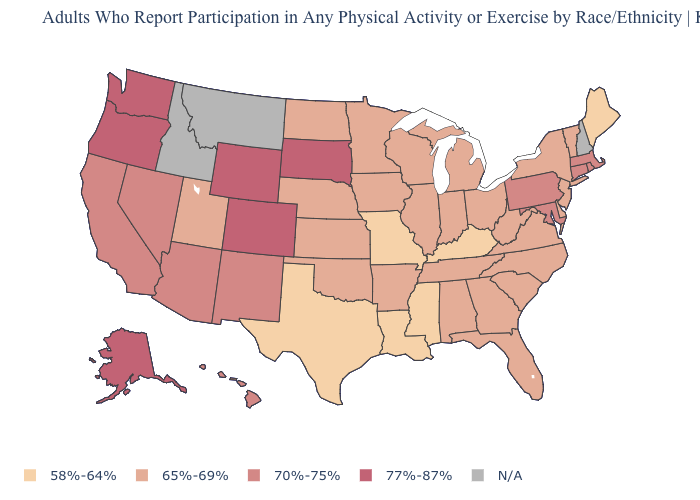How many symbols are there in the legend?
Give a very brief answer. 5. What is the value of Connecticut?
Short answer required. 70%-75%. Which states have the lowest value in the USA?
Short answer required. Kentucky, Louisiana, Maine, Mississippi, Missouri, Texas. Among the states that border California , which have the highest value?
Keep it brief. Oregon. What is the value of West Virginia?
Write a very short answer. 65%-69%. What is the value of Wyoming?
Answer briefly. 77%-87%. What is the lowest value in the USA?
Quick response, please. 58%-64%. What is the value of Tennessee?
Answer briefly. 65%-69%. Name the states that have a value in the range 65%-69%?
Quick response, please. Alabama, Arkansas, Delaware, Florida, Georgia, Illinois, Indiana, Iowa, Kansas, Michigan, Minnesota, Nebraska, New Jersey, New York, North Carolina, North Dakota, Ohio, Oklahoma, South Carolina, Tennessee, Utah, Vermont, Virginia, West Virginia, Wisconsin. What is the highest value in states that border Illinois?
Concise answer only. 65%-69%. Among the states that border Vermont , which have the highest value?
Write a very short answer. Massachusetts. Among the states that border Colorado , which have the highest value?
Give a very brief answer. Wyoming. Name the states that have a value in the range 77%-87%?
Write a very short answer. Alaska, Colorado, Oregon, South Dakota, Washington, Wyoming. 